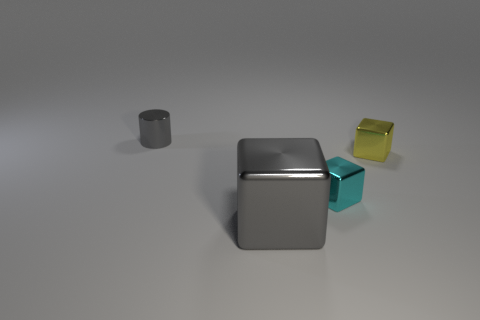Could you describe the lighting and shadows in the scene? The lighting in the image seems diffused, casting soft shadows on the ground. The direction of the shadows suggests a light source coming from the upper left of the scene, creating gentle shading on the objects, which adds depth and dimension to the image. Can you determine the time of day based on the lighting? The image is a computer-generated rendering, making it challenging to infer an actual time of day based on the lighting. However, if this setting were replicated in the real world, the soft and diffused quality of the light could be indicative of a time around early morning or late afternoon when the sun is not at its peak intensity. 